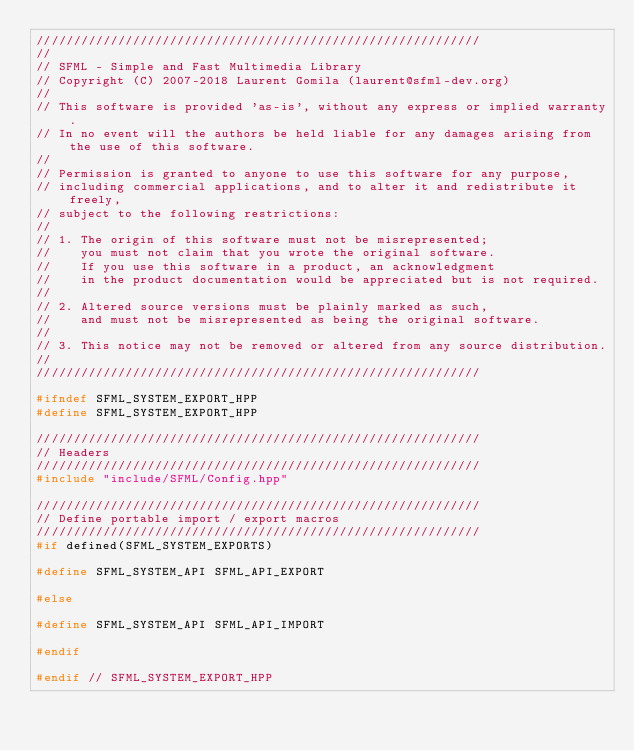Convert code to text. <code><loc_0><loc_0><loc_500><loc_500><_C++_>////////////////////////////////////////////////////////////
//
// SFML - Simple and Fast Multimedia Library
// Copyright (C) 2007-2018 Laurent Gomila (laurent@sfml-dev.org)
//
// This software is provided 'as-is', without any express or implied warranty.
// In no event will the authors be held liable for any damages arising from the use of this software.
//
// Permission is granted to anyone to use this software for any purpose,
// including commercial applications, and to alter it and redistribute it freely,
// subject to the following restrictions:
//
// 1. The origin of this software must not be misrepresented;
//    you must not claim that you wrote the original software.
//    If you use this software in a product, an acknowledgment
//    in the product documentation would be appreciated but is not required.
//
// 2. Altered source versions must be plainly marked as such,
//    and must not be misrepresented as being the original software.
//
// 3. This notice may not be removed or altered from any source distribution.
//
////////////////////////////////////////////////////////////

#ifndef SFML_SYSTEM_EXPORT_HPP
#define SFML_SYSTEM_EXPORT_HPP

////////////////////////////////////////////////////////////
// Headers
////////////////////////////////////////////////////////////
#include "include/SFML/Config.hpp"

////////////////////////////////////////////////////////////
// Define portable import / export macros
////////////////////////////////////////////////////////////
#if defined(SFML_SYSTEM_EXPORTS)

#define SFML_SYSTEM_API SFML_API_EXPORT

#else

#define SFML_SYSTEM_API SFML_API_IMPORT

#endif

#endif // SFML_SYSTEM_EXPORT_HPP
</code> 